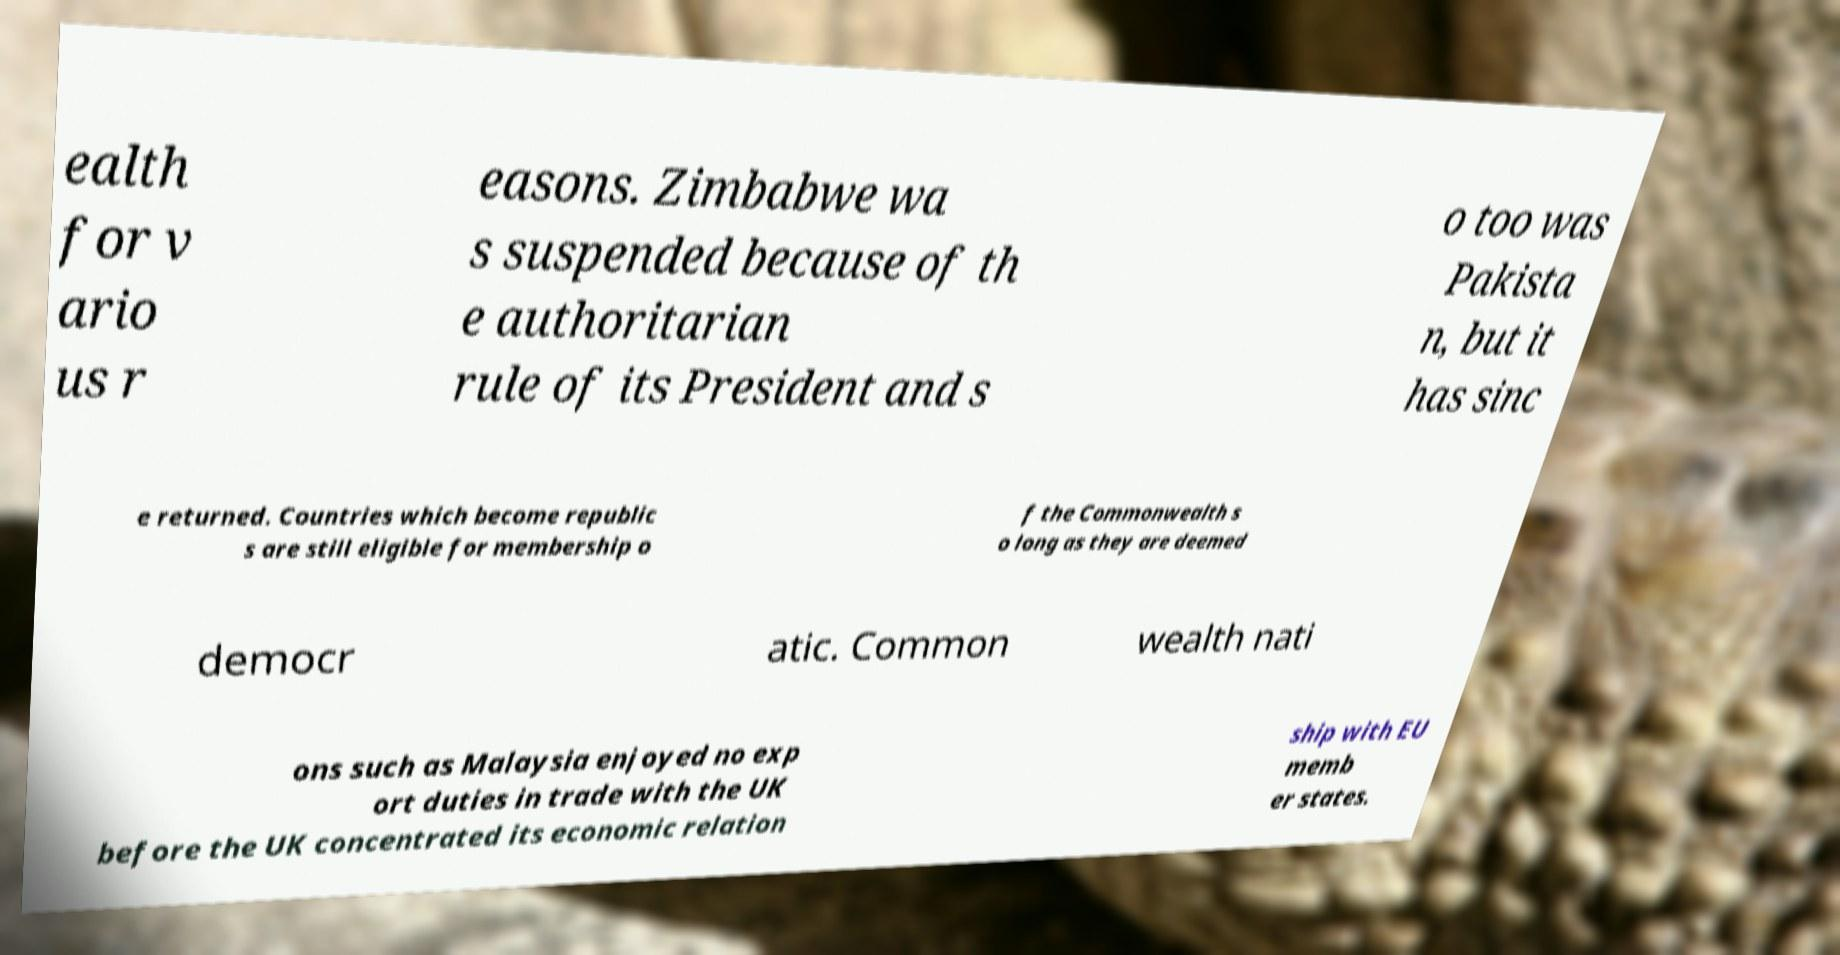Can you read and provide the text displayed in the image?This photo seems to have some interesting text. Can you extract and type it out for me? ealth for v ario us r easons. Zimbabwe wa s suspended because of th e authoritarian rule of its President and s o too was Pakista n, but it has sinc e returned. Countries which become republic s are still eligible for membership o f the Commonwealth s o long as they are deemed democr atic. Common wealth nati ons such as Malaysia enjoyed no exp ort duties in trade with the UK before the UK concentrated its economic relation ship with EU memb er states. 